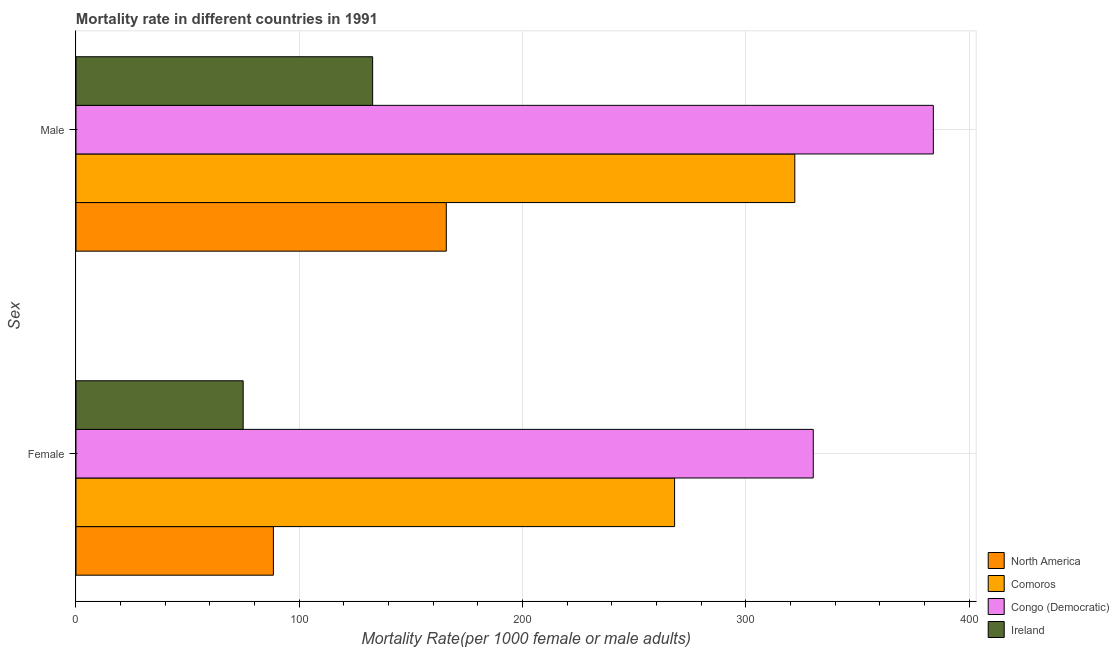How many groups of bars are there?
Provide a short and direct response. 2. How many bars are there on the 2nd tick from the bottom?
Your response must be concise. 4. What is the male mortality rate in North America?
Provide a short and direct response. 165.86. Across all countries, what is the maximum female mortality rate?
Ensure brevity in your answer.  330.23. Across all countries, what is the minimum female mortality rate?
Offer a terse response. 74.88. In which country was the male mortality rate maximum?
Offer a very short reply. Congo (Democratic). In which country was the male mortality rate minimum?
Offer a very short reply. Ireland. What is the total female mortality rate in the graph?
Your response must be concise. 761.65. What is the difference between the male mortality rate in North America and that in Comoros?
Offer a terse response. -156.1. What is the difference between the male mortality rate in Comoros and the female mortality rate in Ireland?
Ensure brevity in your answer.  247.08. What is the average male mortality rate per country?
Give a very brief answer. 251.17. What is the difference between the male mortality rate and female mortality rate in North America?
Keep it short and to the point. 77.45. What is the ratio of the male mortality rate in Comoros to that in North America?
Make the answer very short. 1.94. What does the 2nd bar from the top in Female represents?
Your answer should be very brief. Congo (Democratic). What does the 3rd bar from the bottom in Female represents?
Provide a short and direct response. Congo (Democratic). Are all the bars in the graph horizontal?
Ensure brevity in your answer.  Yes. How many countries are there in the graph?
Your answer should be compact. 4. What is the difference between two consecutive major ticks on the X-axis?
Provide a short and direct response. 100. Are the values on the major ticks of X-axis written in scientific E-notation?
Ensure brevity in your answer.  No. Does the graph contain any zero values?
Make the answer very short. No. Where does the legend appear in the graph?
Provide a short and direct response. Bottom right. What is the title of the graph?
Keep it short and to the point. Mortality rate in different countries in 1991. What is the label or title of the X-axis?
Your response must be concise. Mortality Rate(per 1000 female or male adults). What is the label or title of the Y-axis?
Offer a very short reply. Sex. What is the Mortality Rate(per 1000 female or male adults) in North America in Female?
Keep it short and to the point. 88.41. What is the Mortality Rate(per 1000 female or male adults) of Comoros in Female?
Give a very brief answer. 268.12. What is the Mortality Rate(per 1000 female or male adults) in Congo (Democratic) in Female?
Your answer should be compact. 330.23. What is the Mortality Rate(per 1000 female or male adults) in Ireland in Female?
Provide a succinct answer. 74.88. What is the Mortality Rate(per 1000 female or male adults) in North America in Male?
Your answer should be compact. 165.86. What is the Mortality Rate(per 1000 female or male adults) in Comoros in Male?
Give a very brief answer. 321.96. What is the Mortality Rate(per 1000 female or male adults) of Congo (Democratic) in Male?
Provide a succinct answer. 384. What is the Mortality Rate(per 1000 female or male adults) of Ireland in Male?
Provide a short and direct response. 132.87. Across all Sex, what is the maximum Mortality Rate(per 1000 female or male adults) of North America?
Make the answer very short. 165.86. Across all Sex, what is the maximum Mortality Rate(per 1000 female or male adults) in Comoros?
Ensure brevity in your answer.  321.96. Across all Sex, what is the maximum Mortality Rate(per 1000 female or male adults) in Congo (Democratic)?
Your answer should be compact. 384. Across all Sex, what is the maximum Mortality Rate(per 1000 female or male adults) of Ireland?
Make the answer very short. 132.87. Across all Sex, what is the minimum Mortality Rate(per 1000 female or male adults) of North America?
Your answer should be compact. 88.41. Across all Sex, what is the minimum Mortality Rate(per 1000 female or male adults) in Comoros?
Give a very brief answer. 268.12. Across all Sex, what is the minimum Mortality Rate(per 1000 female or male adults) of Congo (Democratic)?
Your answer should be very brief. 330.23. Across all Sex, what is the minimum Mortality Rate(per 1000 female or male adults) in Ireland?
Give a very brief answer. 74.88. What is the total Mortality Rate(per 1000 female or male adults) in North America in the graph?
Make the answer very short. 254.27. What is the total Mortality Rate(per 1000 female or male adults) in Comoros in the graph?
Your answer should be very brief. 590.08. What is the total Mortality Rate(per 1000 female or male adults) in Congo (Democratic) in the graph?
Your response must be concise. 714.23. What is the total Mortality Rate(per 1000 female or male adults) of Ireland in the graph?
Your response must be concise. 207.75. What is the difference between the Mortality Rate(per 1000 female or male adults) of North America in Female and that in Male?
Make the answer very short. -77.45. What is the difference between the Mortality Rate(per 1000 female or male adults) of Comoros in Female and that in Male?
Offer a terse response. -53.84. What is the difference between the Mortality Rate(per 1000 female or male adults) in Congo (Democratic) in Female and that in Male?
Provide a succinct answer. -53.77. What is the difference between the Mortality Rate(per 1000 female or male adults) in Ireland in Female and that in Male?
Make the answer very short. -57.99. What is the difference between the Mortality Rate(per 1000 female or male adults) in North America in Female and the Mortality Rate(per 1000 female or male adults) in Comoros in Male?
Your response must be concise. -233.55. What is the difference between the Mortality Rate(per 1000 female or male adults) in North America in Female and the Mortality Rate(per 1000 female or male adults) in Congo (Democratic) in Male?
Your answer should be very brief. -295.59. What is the difference between the Mortality Rate(per 1000 female or male adults) of North America in Female and the Mortality Rate(per 1000 female or male adults) of Ireland in Male?
Make the answer very short. -44.46. What is the difference between the Mortality Rate(per 1000 female or male adults) in Comoros in Female and the Mortality Rate(per 1000 female or male adults) in Congo (Democratic) in Male?
Your answer should be very brief. -115.89. What is the difference between the Mortality Rate(per 1000 female or male adults) in Comoros in Female and the Mortality Rate(per 1000 female or male adults) in Ireland in Male?
Your answer should be compact. 135.25. What is the difference between the Mortality Rate(per 1000 female or male adults) of Congo (Democratic) in Female and the Mortality Rate(per 1000 female or male adults) of Ireland in Male?
Your answer should be very brief. 197.36. What is the average Mortality Rate(per 1000 female or male adults) in North America per Sex?
Make the answer very short. 127.14. What is the average Mortality Rate(per 1000 female or male adults) in Comoros per Sex?
Your response must be concise. 295.04. What is the average Mortality Rate(per 1000 female or male adults) of Congo (Democratic) per Sex?
Ensure brevity in your answer.  357.12. What is the average Mortality Rate(per 1000 female or male adults) in Ireland per Sex?
Offer a terse response. 103.88. What is the difference between the Mortality Rate(per 1000 female or male adults) in North America and Mortality Rate(per 1000 female or male adults) in Comoros in Female?
Your answer should be very brief. -179.7. What is the difference between the Mortality Rate(per 1000 female or male adults) of North America and Mortality Rate(per 1000 female or male adults) of Congo (Democratic) in Female?
Provide a succinct answer. -241.81. What is the difference between the Mortality Rate(per 1000 female or male adults) of North America and Mortality Rate(per 1000 female or male adults) of Ireland in Female?
Offer a very short reply. 13.53. What is the difference between the Mortality Rate(per 1000 female or male adults) in Comoros and Mortality Rate(per 1000 female or male adults) in Congo (Democratic) in Female?
Make the answer very short. -62.11. What is the difference between the Mortality Rate(per 1000 female or male adults) of Comoros and Mortality Rate(per 1000 female or male adults) of Ireland in Female?
Ensure brevity in your answer.  193.24. What is the difference between the Mortality Rate(per 1000 female or male adults) in Congo (Democratic) and Mortality Rate(per 1000 female or male adults) in Ireland in Female?
Make the answer very short. 255.35. What is the difference between the Mortality Rate(per 1000 female or male adults) in North America and Mortality Rate(per 1000 female or male adults) in Comoros in Male?
Provide a short and direct response. -156.1. What is the difference between the Mortality Rate(per 1000 female or male adults) in North America and Mortality Rate(per 1000 female or male adults) in Congo (Democratic) in Male?
Your answer should be compact. -218.14. What is the difference between the Mortality Rate(per 1000 female or male adults) of North America and Mortality Rate(per 1000 female or male adults) of Ireland in Male?
Offer a terse response. 32.99. What is the difference between the Mortality Rate(per 1000 female or male adults) in Comoros and Mortality Rate(per 1000 female or male adults) in Congo (Democratic) in Male?
Keep it short and to the point. -62.04. What is the difference between the Mortality Rate(per 1000 female or male adults) of Comoros and Mortality Rate(per 1000 female or male adults) of Ireland in Male?
Offer a very short reply. 189.09. What is the difference between the Mortality Rate(per 1000 female or male adults) of Congo (Democratic) and Mortality Rate(per 1000 female or male adults) of Ireland in Male?
Offer a very short reply. 251.13. What is the ratio of the Mortality Rate(per 1000 female or male adults) of North America in Female to that in Male?
Offer a terse response. 0.53. What is the ratio of the Mortality Rate(per 1000 female or male adults) of Comoros in Female to that in Male?
Your response must be concise. 0.83. What is the ratio of the Mortality Rate(per 1000 female or male adults) in Congo (Democratic) in Female to that in Male?
Your answer should be compact. 0.86. What is the ratio of the Mortality Rate(per 1000 female or male adults) in Ireland in Female to that in Male?
Offer a very short reply. 0.56. What is the difference between the highest and the second highest Mortality Rate(per 1000 female or male adults) of North America?
Ensure brevity in your answer.  77.45. What is the difference between the highest and the second highest Mortality Rate(per 1000 female or male adults) in Comoros?
Your response must be concise. 53.84. What is the difference between the highest and the second highest Mortality Rate(per 1000 female or male adults) of Congo (Democratic)?
Make the answer very short. 53.77. What is the difference between the highest and the second highest Mortality Rate(per 1000 female or male adults) of Ireland?
Your response must be concise. 57.99. What is the difference between the highest and the lowest Mortality Rate(per 1000 female or male adults) in North America?
Make the answer very short. 77.45. What is the difference between the highest and the lowest Mortality Rate(per 1000 female or male adults) in Comoros?
Your response must be concise. 53.84. What is the difference between the highest and the lowest Mortality Rate(per 1000 female or male adults) in Congo (Democratic)?
Make the answer very short. 53.77. What is the difference between the highest and the lowest Mortality Rate(per 1000 female or male adults) in Ireland?
Your answer should be very brief. 57.99. 